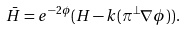Convert formula to latex. <formula><loc_0><loc_0><loc_500><loc_500>\bar { H } = e ^ { - 2 \phi } ( H - k ( \pi ^ { \perp } \nabla \phi ) ) .</formula> 